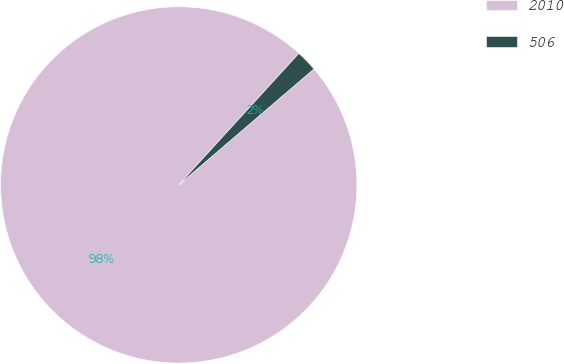Convert chart to OTSL. <chart><loc_0><loc_0><loc_500><loc_500><pie_chart><fcel>2010<fcel>506<nl><fcel>98.06%<fcel>1.94%<nl></chart> 